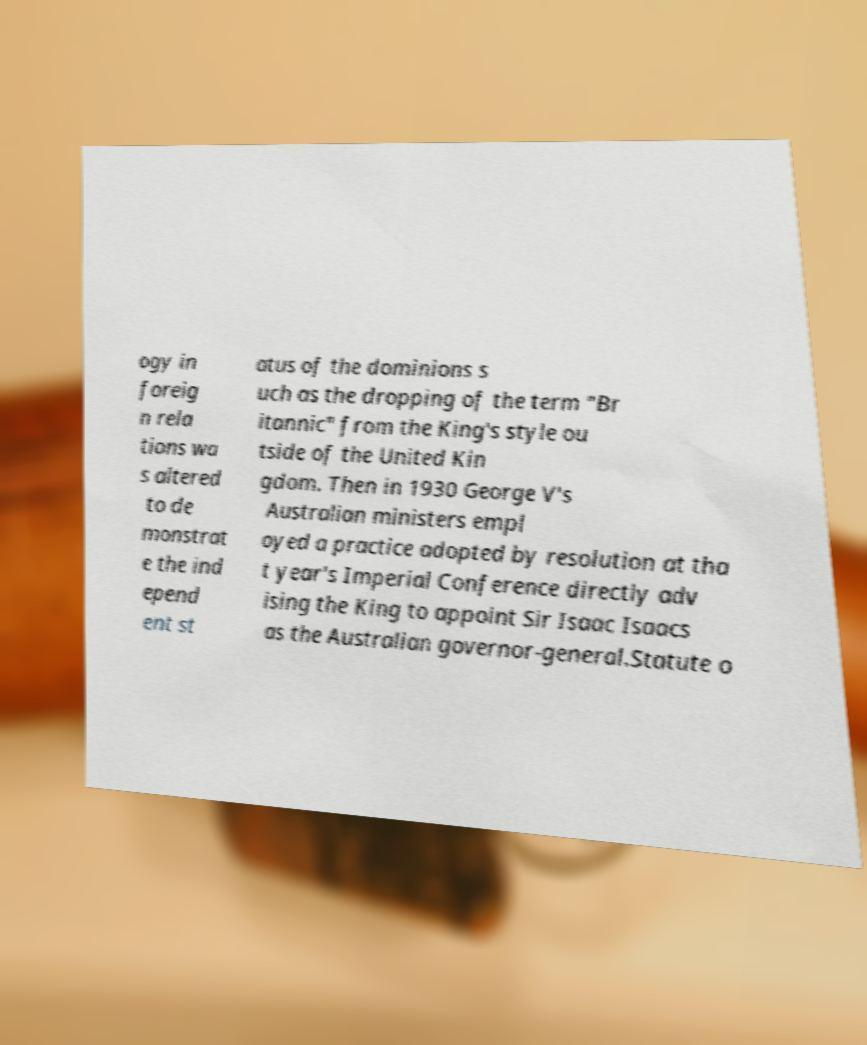Could you extract and type out the text from this image? ogy in foreig n rela tions wa s altered to de monstrat e the ind epend ent st atus of the dominions s uch as the dropping of the term "Br itannic" from the King's style ou tside of the United Kin gdom. Then in 1930 George V's Australian ministers empl oyed a practice adopted by resolution at tha t year's Imperial Conference directly adv ising the King to appoint Sir Isaac Isaacs as the Australian governor-general.Statute o 